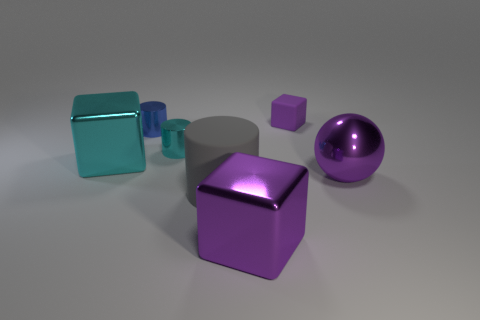Subtract all purple cylinders. How many purple cubes are left? 2 Subtract all tiny cylinders. How many cylinders are left? 1 Add 1 cyan cylinders. How many objects exist? 8 Subtract 1 cylinders. How many cylinders are left? 2 Subtract all cylinders. How many objects are left? 4 Subtract all green blocks. Subtract all blue spheres. How many blocks are left? 3 Subtract all cyan shiny blocks. Subtract all purple matte things. How many objects are left? 5 Add 7 large gray rubber cylinders. How many large gray rubber cylinders are left? 8 Add 1 big brown spheres. How many big brown spheres exist? 1 Subtract 0 red cubes. How many objects are left? 7 